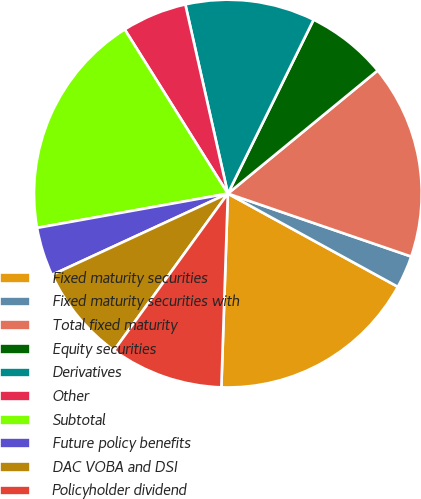<chart> <loc_0><loc_0><loc_500><loc_500><pie_chart><fcel>Fixed maturity securities<fcel>Fixed maturity securities with<fcel>Total fixed maturity<fcel>Equity securities<fcel>Derivatives<fcel>Other<fcel>Subtotal<fcel>Future policy benefits<fcel>DAC VOBA and DSI<fcel>Policyholder dividend<nl><fcel>17.55%<fcel>2.72%<fcel>16.21%<fcel>6.76%<fcel>10.81%<fcel>5.41%<fcel>18.9%<fcel>4.06%<fcel>8.11%<fcel>9.46%<nl></chart> 